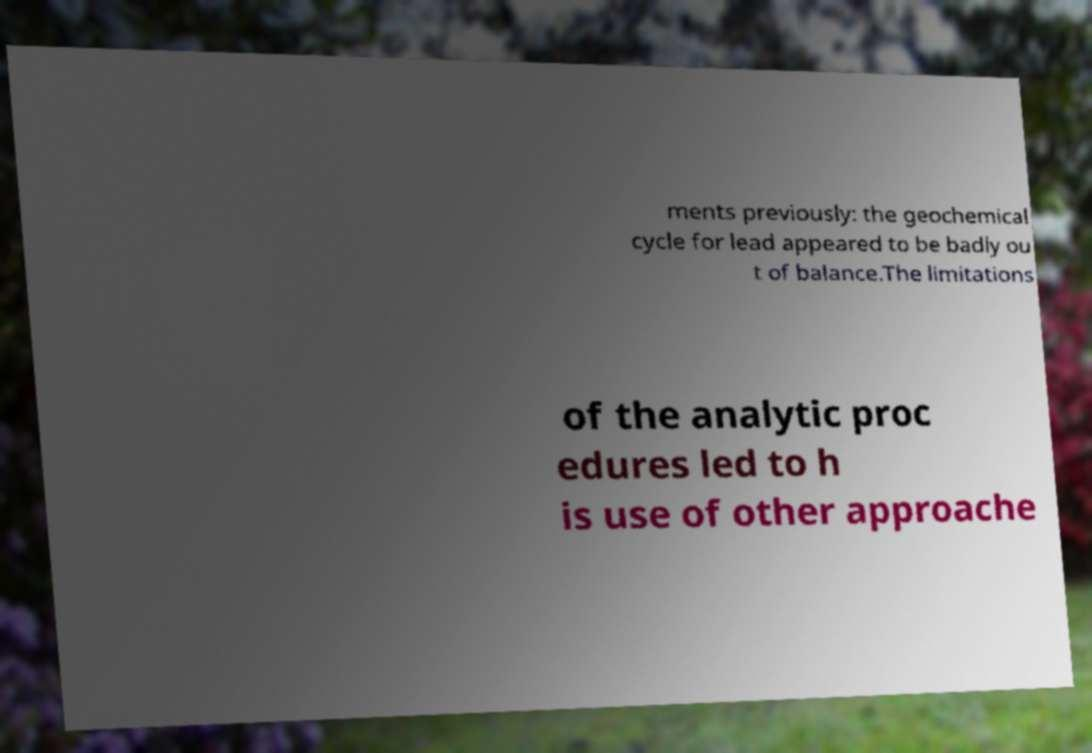There's text embedded in this image that I need extracted. Can you transcribe it verbatim? ments previously: the geochemical cycle for lead appeared to be badly ou t of balance.The limitations of the analytic proc edures led to h is use of other approache 